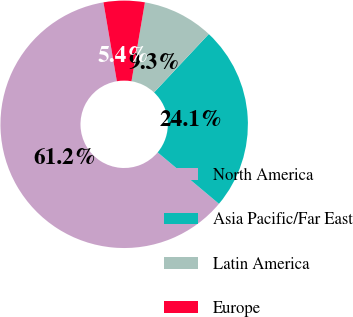Convert chart to OTSL. <chart><loc_0><loc_0><loc_500><loc_500><pie_chart><fcel>North America<fcel>Asia Pacific/Far East<fcel>Latin America<fcel>Europe<nl><fcel>61.21%<fcel>24.12%<fcel>9.3%<fcel>5.36%<nl></chart> 